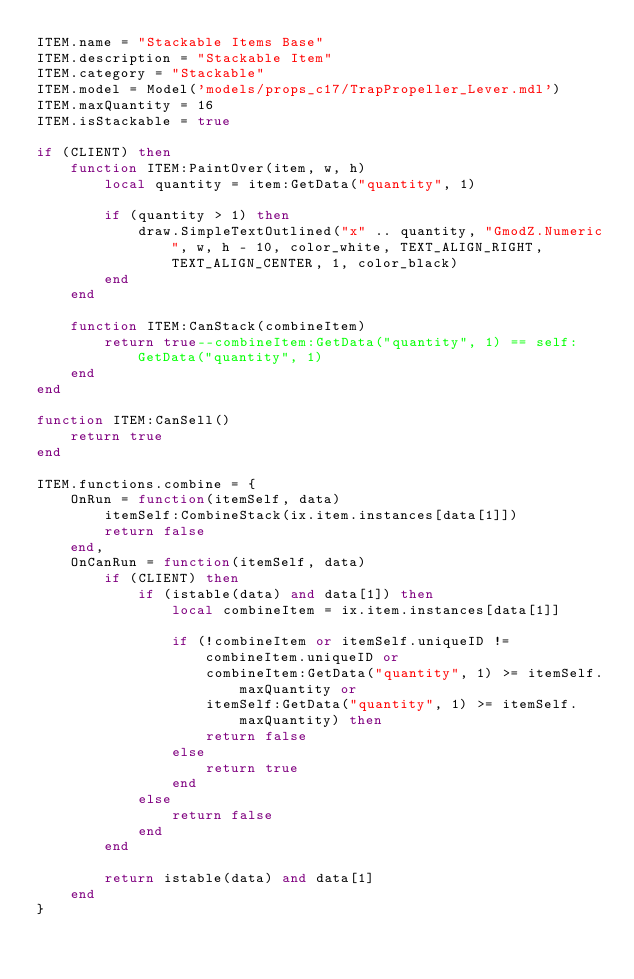Convert code to text. <code><loc_0><loc_0><loc_500><loc_500><_Lua_>ITEM.name = "Stackable Items Base"
ITEM.description = "Stackable Item"
ITEM.category = "Stackable"
ITEM.model = Model('models/props_c17/TrapPropeller_Lever.mdl')
ITEM.maxQuantity = 16
ITEM.isStackable = true

if (CLIENT) then
	function ITEM:PaintOver(item, w, h)
		local quantity = item:GetData("quantity", 1)

		if (quantity > 1) then
			draw.SimpleTextOutlined("x" .. quantity, "GmodZ.Numeric", w, h - 10, color_white, TEXT_ALIGN_RIGHT, TEXT_ALIGN_CENTER, 1, color_black)
		end
	end

	function ITEM:CanStack(combineItem)
		return true--combineItem:GetData("quantity", 1) == self:GetData("quantity", 1)
	end
end

function ITEM:CanSell()
	return true
end

ITEM.functions.combine = {
	OnRun = function(itemSelf, data)
		itemSelf:CombineStack(ix.item.instances[data[1]])
		return false
	end,
	OnCanRun = function(itemSelf, data)
		if (CLIENT) then
			if (istable(data) and data[1]) then
				local combineItem = ix.item.instances[data[1]]

				if (!combineItem or itemSelf.uniqueID != combineItem.uniqueID or 
					combineItem:GetData("quantity", 1) >= itemSelf.maxQuantity or
					itemSelf:GetData("quantity", 1) >= itemSelf.maxQuantity) then 
					return false
				else
					return true
				end
			else
				return false
			end
		end

		return istable(data) and data[1]
	end
}</code> 